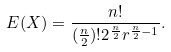Convert formula to latex. <formula><loc_0><loc_0><loc_500><loc_500>E ( X ) = \frac { n ! } { ( \frac { n } { 2 } ) ! 2 ^ { \frac { n } { 2 } } r ^ { \frac { n } { 2 } - 1 } } .</formula> 